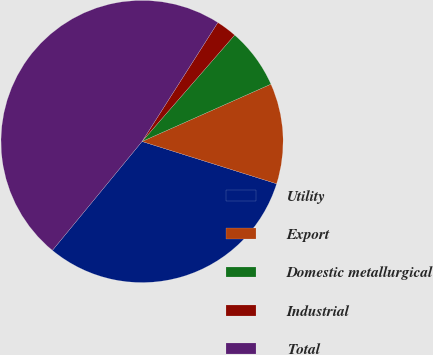Convert chart to OTSL. <chart><loc_0><loc_0><loc_500><loc_500><pie_chart><fcel>Utility<fcel>Export<fcel>Domestic metallurgical<fcel>Industrial<fcel>Total<nl><fcel>31.12%<fcel>11.51%<fcel>6.94%<fcel>2.37%<fcel>48.07%<nl></chart> 